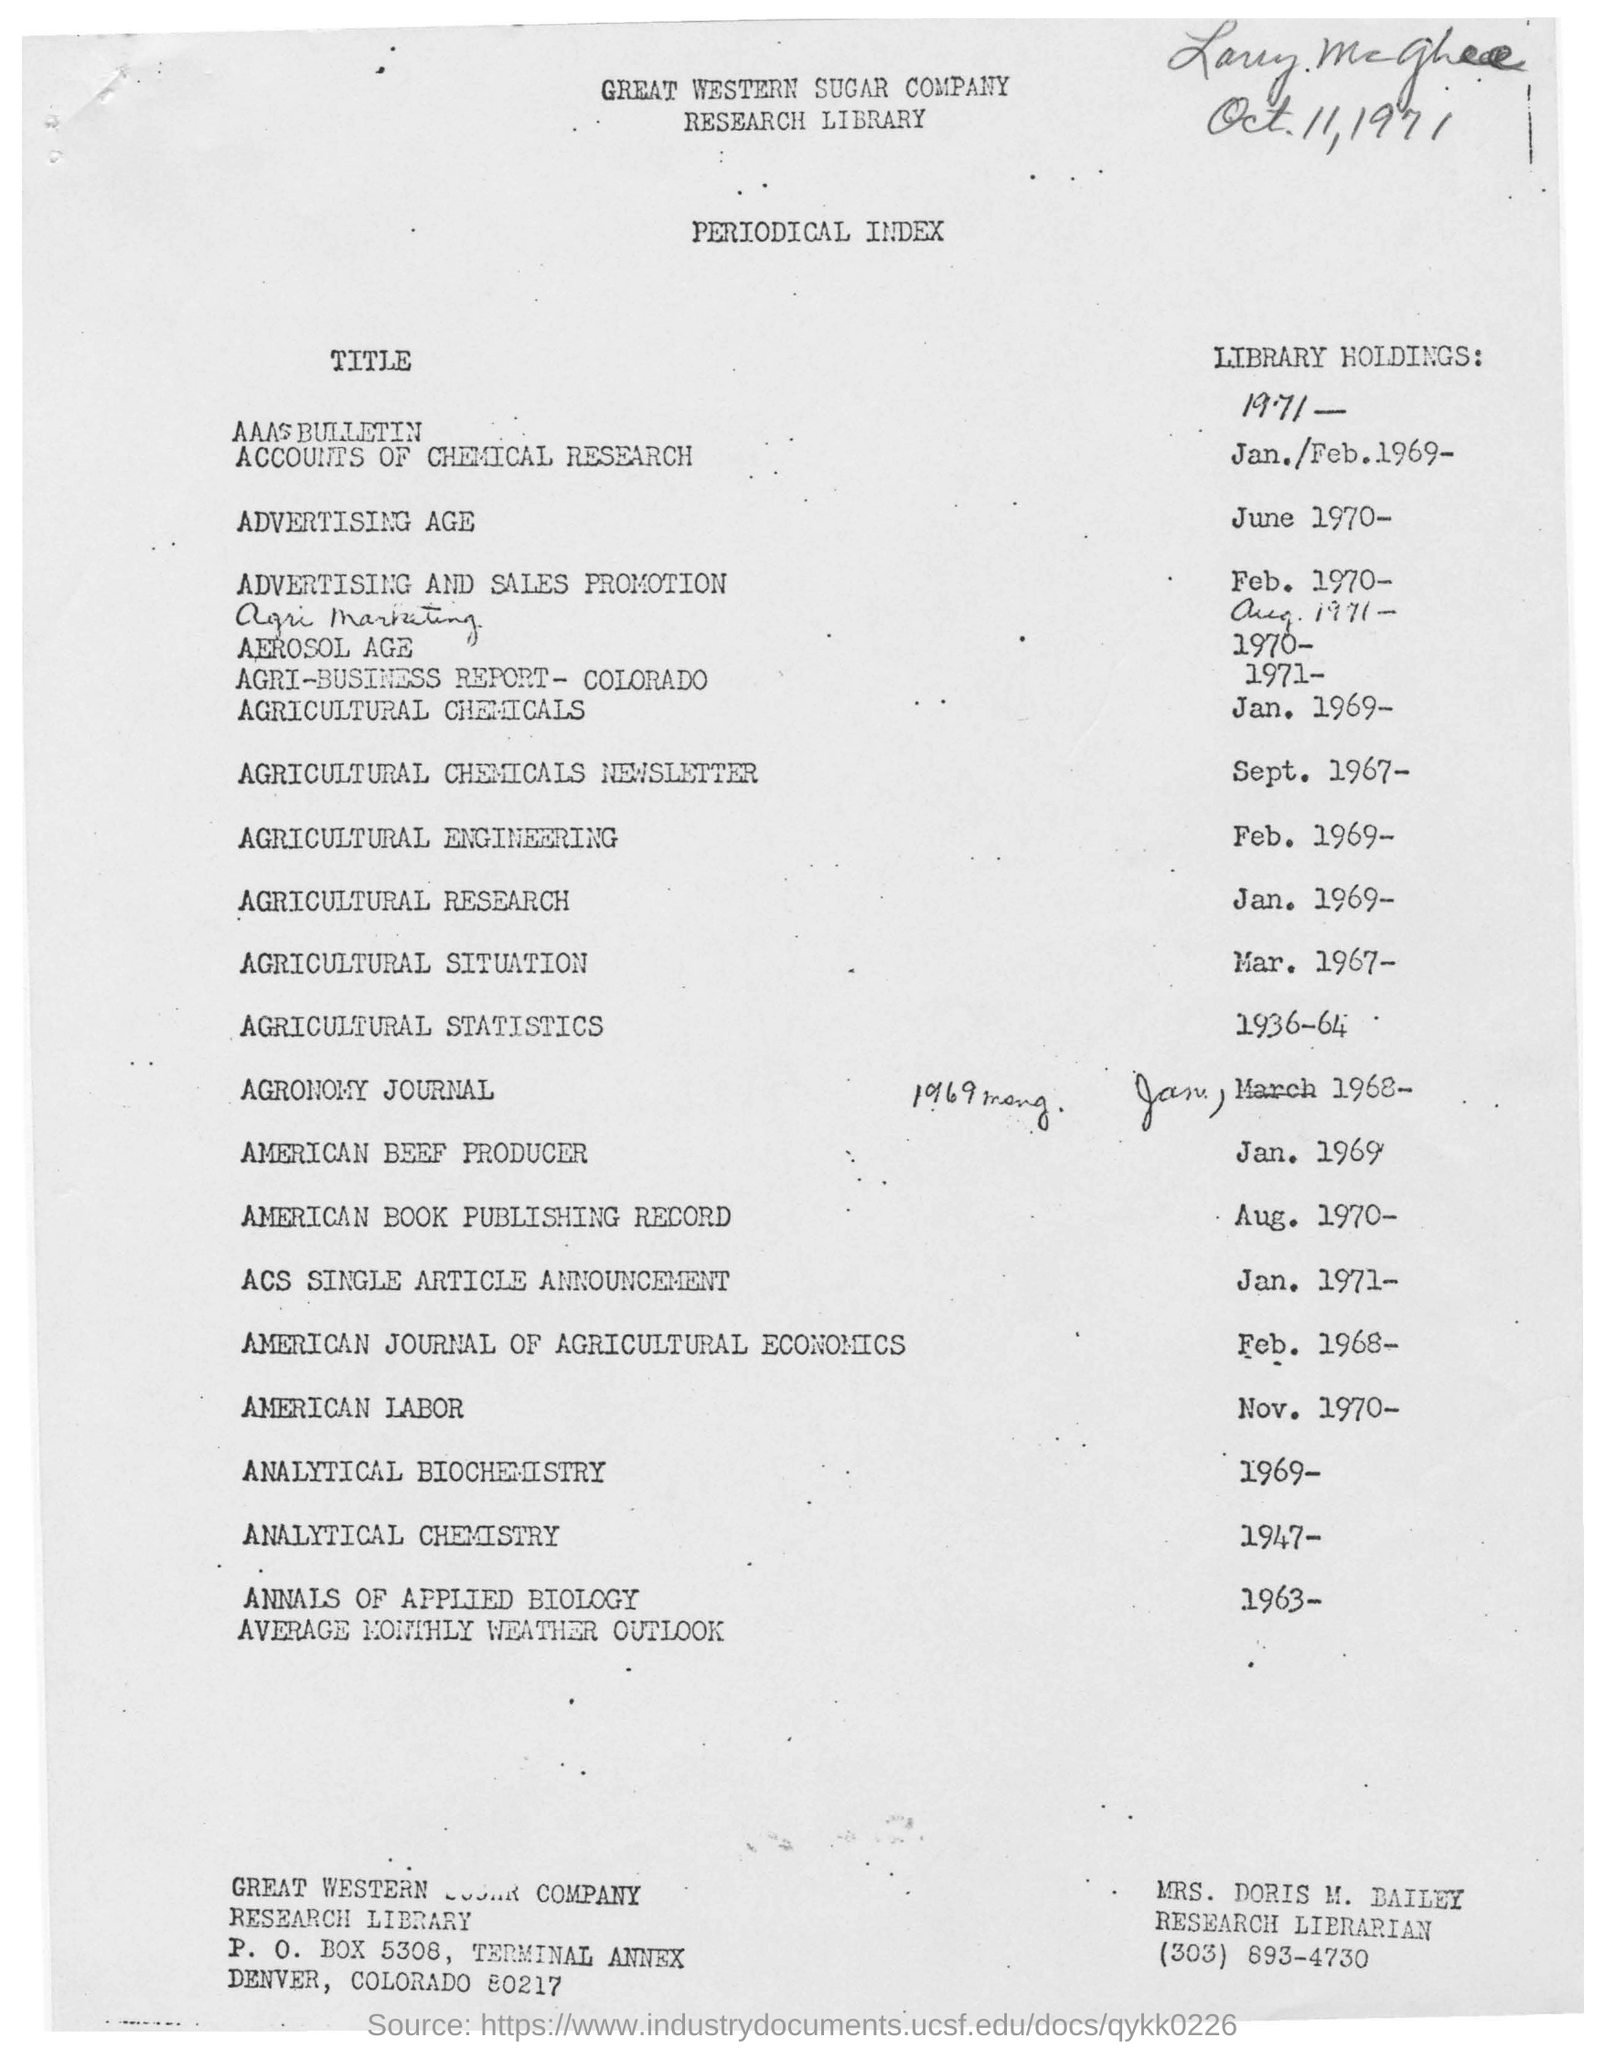Highlight a few significant elements in this photo. The P.O. box number of Great Western Sugar Company is 5308. The handwritten date in the document is "Oct. 11, 1971. The name of the company is the Great Western Sugar Company. The periodical index is a type of index that provides access to articles and other materials published in periodicals. The name of Mrs. Doris M. Bailey is mentioned below the document. 